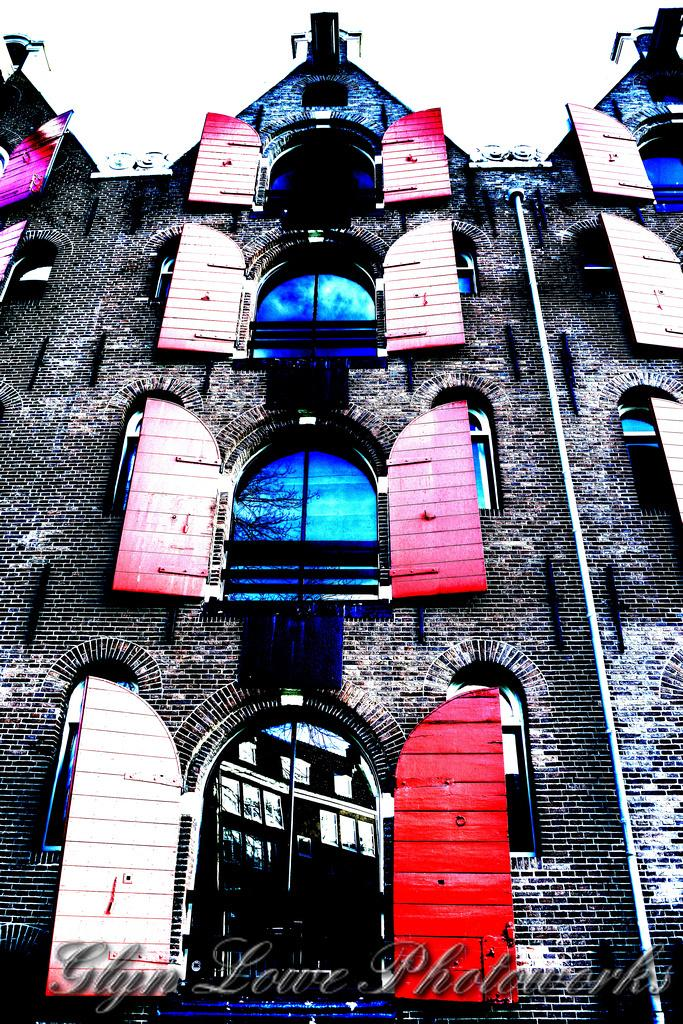What type of structure is visible in the image? There is a building in the image. What features can be seen on the building? The building has doors and windows. Is there any text present in the image? Yes, there is text at the bottom of the image. What type of pie is being served on the windowsill in the image? There is no pie present in the image; it only features a building with doors and windows, and text at the bottom. 